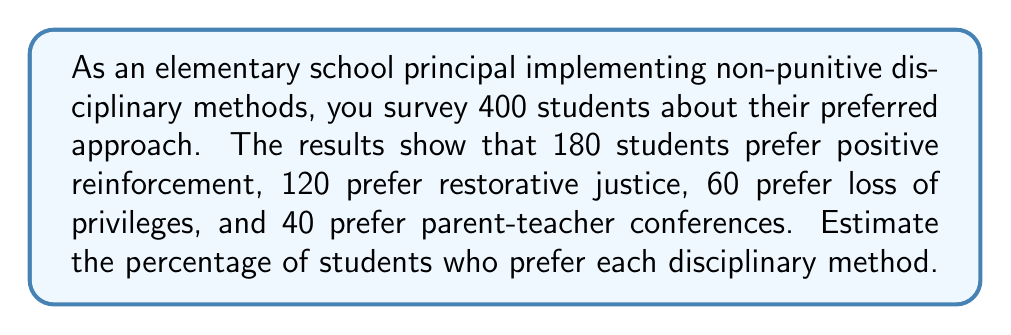Provide a solution to this math problem. To estimate the percentage of students who prefer each disciplinary method, we need to divide the number of students who chose each method by the total number of students surveyed, then multiply by 100.

Total students surveyed: 400

1. Positive reinforcement:
   $\frac{180}{400} \times 100 = 45\%$

2. Restorative justice:
   $\frac{120}{400} \times 100 = 30\%$

3. Loss of privileges:
   $\frac{60}{400} \times 100 = 15\%$

4. Parent-teacher conferences:
   $\frac{40}{400} \times 100 = 10\%$

To verify our calculations, we can sum the percentages:
$45\% + 30\% + 15\% + 10\% = 100\%$

This confirms that our percentages account for all students surveyed.
Answer: Positive reinforcement: 45%, Restorative justice: 30%, Loss of privileges: 15%, Parent-teacher conferences: 10% 